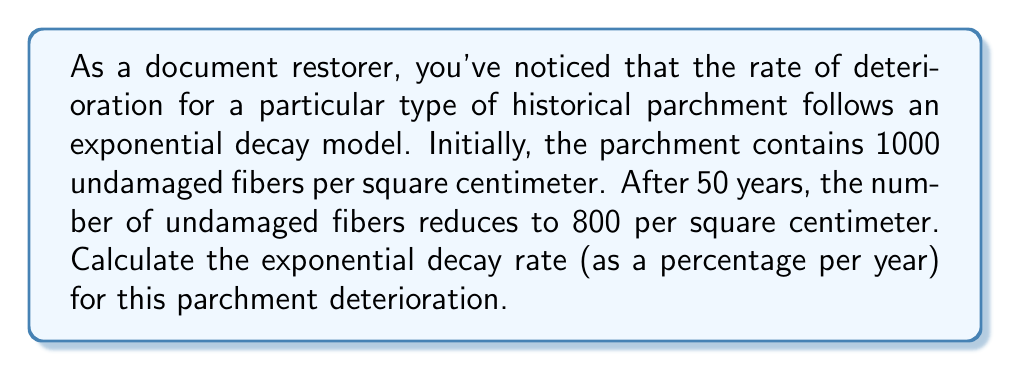Give your solution to this math problem. To solve this problem, we'll use the exponential decay formula:

$$A(t) = A_0 e^{-rt}$$

Where:
$A(t)$ is the amount at time $t$
$A_0$ is the initial amount
$r$ is the decay rate
$t$ is the time

We know:
$A_0 = 1000$ (initial undamaged fibers)
$A(50) = 800$ (undamaged fibers after 50 years)
$t = 50$ years

Let's plug these values into the formula:

$$800 = 1000 e^{-r(50)}$$

Now, let's solve for $r$:

1) Divide both sides by 1000:
   $$0.8 = e^{-50r}$$

2) Take the natural log of both sides:
   $$\ln(0.8) = -50r$$

3) Solve for $r$:
   $$r = -\frac{\ln(0.8)}{50}$$

4) Calculate the value:
   $$r = -\frac{\ln(0.8)}{50} \approx 0.004462$$

5) Convert to a percentage:
   $$0.004462 \times 100\% \approx 0.4462\%$$

Therefore, the exponential decay rate is approximately 0.4462% per year.
Answer: The exponential decay rate for the parchment deterioration is approximately 0.4462% per year. 